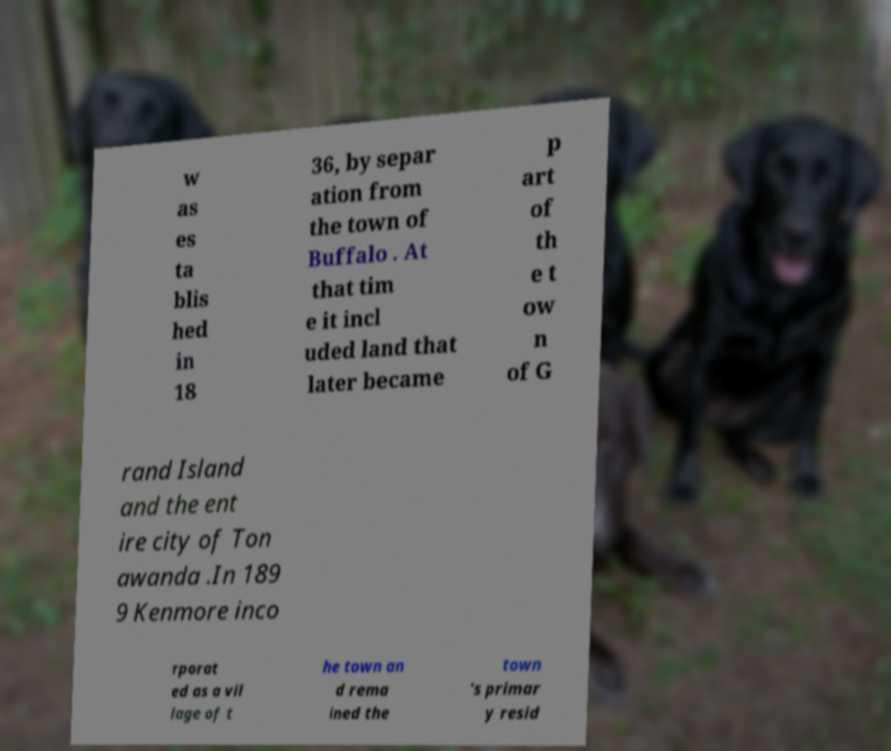There's text embedded in this image that I need extracted. Can you transcribe it verbatim? w as es ta blis hed in 18 36, by separ ation from the town of Buffalo . At that tim e it incl uded land that later became p art of th e t ow n of G rand Island and the ent ire city of Ton awanda .In 189 9 Kenmore inco rporat ed as a vil lage of t he town an d rema ined the town 's primar y resid 